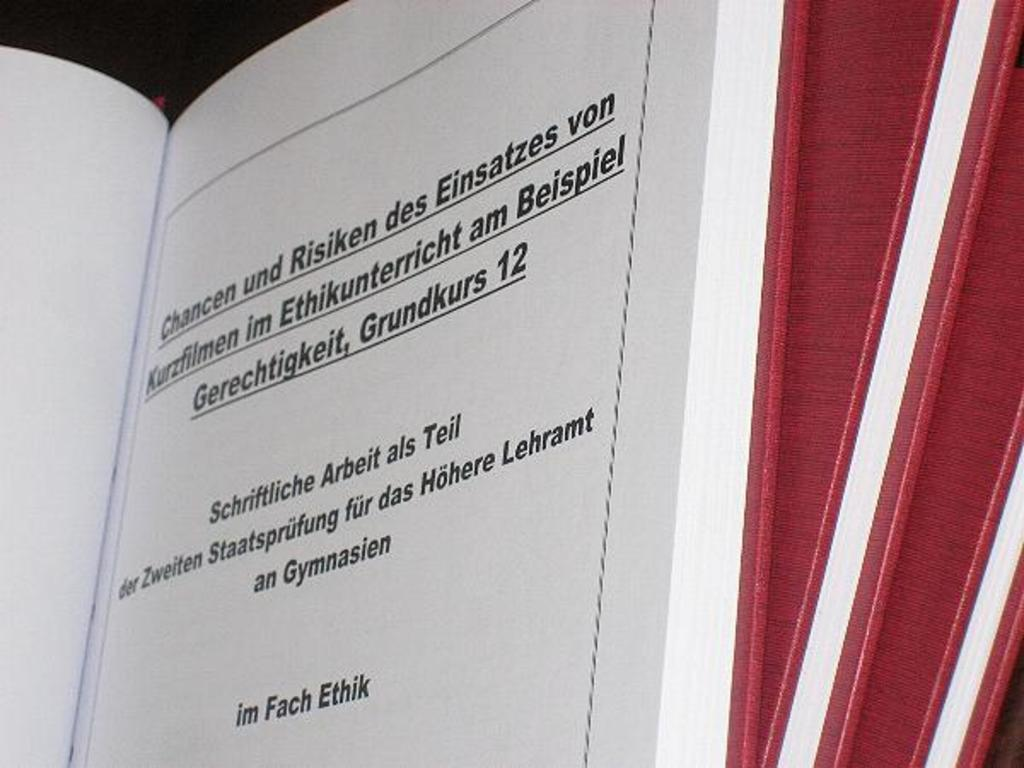<image>
Provide a brief description of the given image. Page of a book that says "im Fach Ethik" near the bottom. 